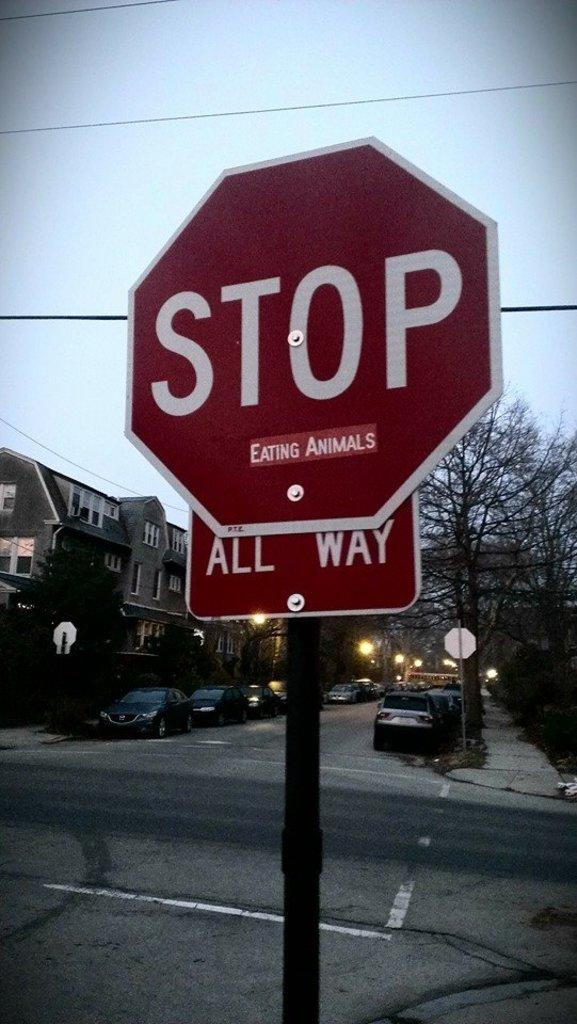What is on the sticker on the stop sign?
Keep it short and to the point. Eating animals. 